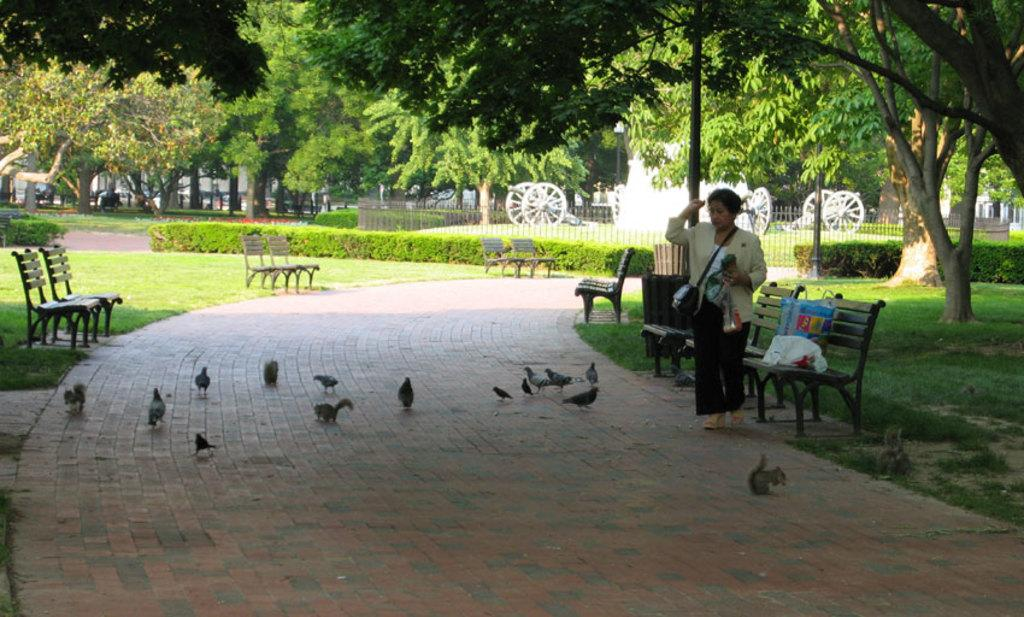What type of natural elements can be seen in the image? There are trees and plants in the image. What type of man-made structures are present in the image? There are benches in the image. What type of transportation-related feature is visible in the image? There are wheels in the image. Who is present in the image? A woman is standing in the image. What is the woman wearing? The woman is wearing a bag. What type of animals can be seen on the floor in the image? Squirrels and birds are on the floor in the image. Where is another bag located in the image? There is a bag on one of the benches. What type of tax system is being discussed in the image? There is no discussion of a tax system in the image; it features trees, plants, benches, wheels, a woman, a bag, squirrels, birds, and another bag on a bench. What type of art is displayed on the benches in the image? There is no art displayed on the benches in the image; the benches are simply benches. 